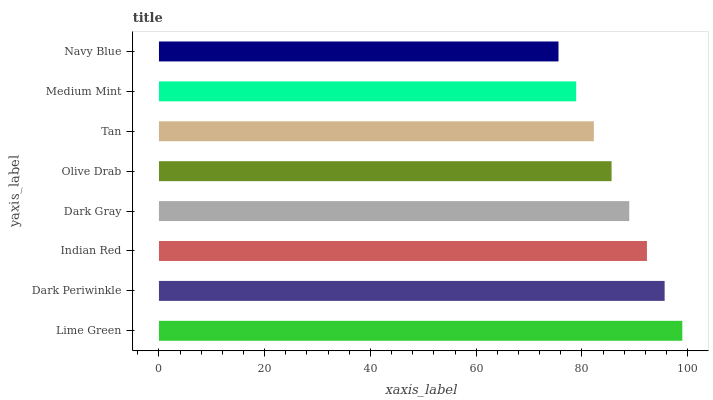Is Navy Blue the minimum?
Answer yes or no. Yes. Is Lime Green the maximum?
Answer yes or no. Yes. Is Dark Periwinkle the minimum?
Answer yes or no. No. Is Dark Periwinkle the maximum?
Answer yes or no. No. Is Lime Green greater than Dark Periwinkle?
Answer yes or no. Yes. Is Dark Periwinkle less than Lime Green?
Answer yes or no. Yes. Is Dark Periwinkle greater than Lime Green?
Answer yes or no. No. Is Lime Green less than Dark Periwinkle?
Answer yes or no. No. Is Dark Gray the high median?
Answer yes or no. Yes. Is Olive Drab the low median?
Answer yes or no. Yes. Is Olive Drab the high median?
Answer yes or no. No. Is Medium Mint the low median?
Answer yes or no. No. 